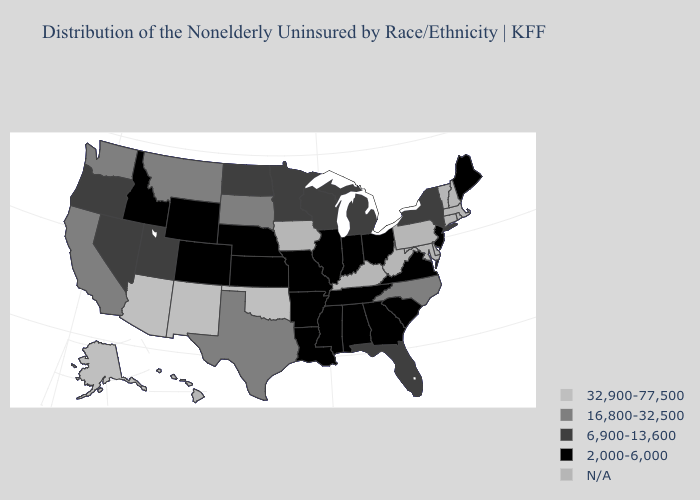Name the states that have a value in the range 2,000-6,000?
Concise answer only. Alabama, Arkansas, Colorado, Georgia, Idaho, Illinois, Indiana, Kansas, Louisiana, Maine, Mississippi, Missouri, Nebraska, New Jersey, Ohio, South Carolina, Tennessee, Virginia, Wyoming. Among the states that border Louisiana , does Arkansas have the highest value?
Short answer required. No. What is the highest value in states that border Pennsylvania?
Write a very short answer. 6,900-13,600. Does the map have missing data?
Answer briefly. Yes. What is the highest value in the South ?
Keep it brief. 32,900-77,500. Which states have the highest value in the USA?
Quick response, please. Alaska, Arizona, New Mexico, Oklahoma. Does Oklahoma have the lowest value in the South?
Give a very brief answer. No. What is the value of Idaho?
Short answer required. 2,000-6,000. Which states have the lowest value in the USA?
Write a very short answer. Alabama, Arkansas, Colorado, Georgia, Idaho, Illinois, Indiana, Kansas, Louisiana, Maine, Mississippi, Missouri, Nebraska, New Jersey, Ohio, South Carolina, Tennessee, Virginia, Wyoming. What is the highest value in the Northeast ?
Be succinct. 6,900-13,600. Does Virginia have the lowest value in the South?
Be succinct. Yes. Name the states that have a value in the range 6,900-13,600?
Quick response, please. Florida, Michigan, Minnesota, Nevada, New York, North Dakota, Oregon, Utah, Wisconsin. Which states hav the highest value in the South?
Keep it brief. Oklahoma. What is the value of Pennsylvania?
Give a very brief answer. N/A. 